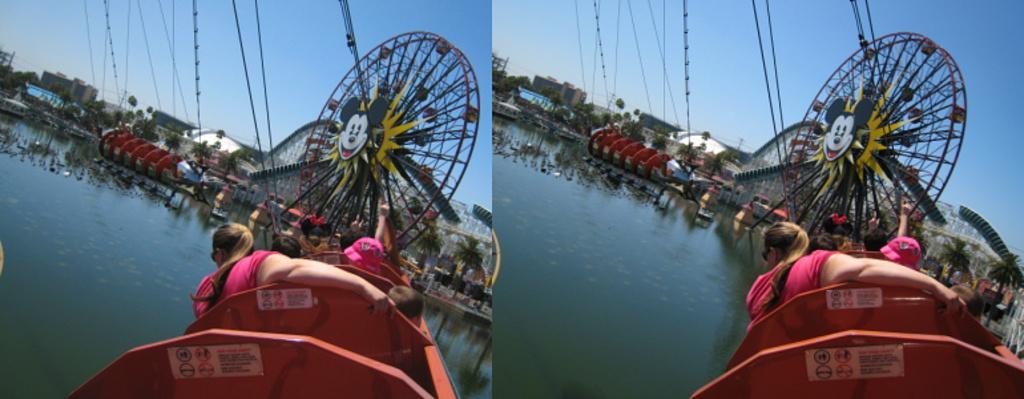Could you give a brief overview of what you see in this image? In this picture there are rollercoaster hump photographs. 